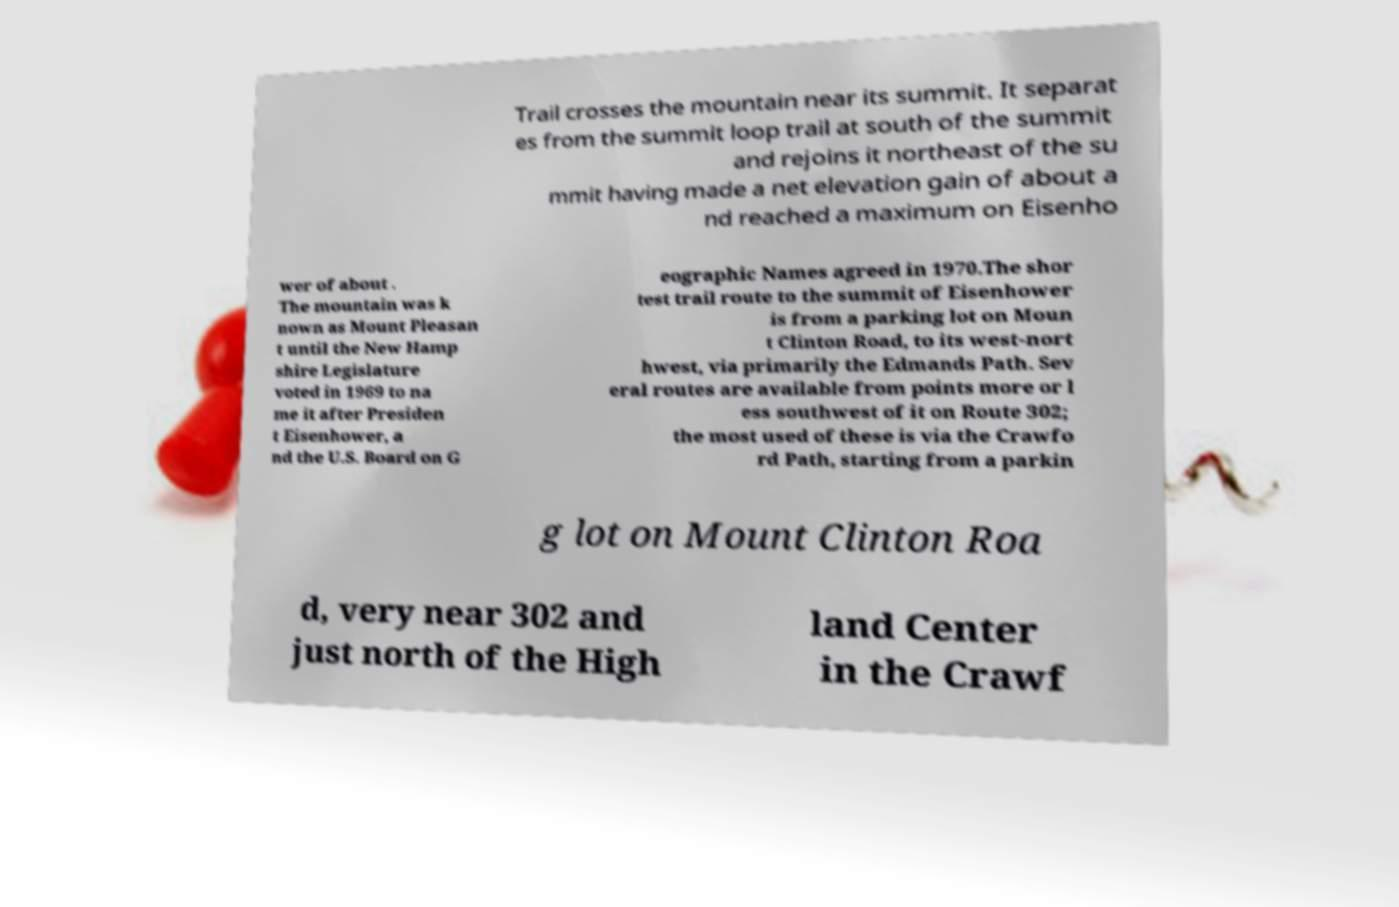Please read and relay the text visible in this image. What does it say? Trail crosses the mountain near its summit. It separat es from the summit loop trail at south of the summit and rejoins it northeast of the su mmit having made a net elevation gain of about a nd reached a maximum on Eisenho wer of about . The mountain was k nown as Mount Pleasan t until the New Hamp shire Legislature voted in 1969 to na me it after Presiden t Eisenhower, a nd the U.S. Board on G eographic Names agreed in 1970.The shor test trail route to the summit of Eisenhower is from a parking lot on Moun t Clinton Road, to its west-nort hwest, via primarily the Edmands Path. Sev eral routes are available from points more or l ess southwest of it on Route 302; the most used of these is via the Crawfo rd Path, starting from a parkin g lot on Mount Clinton Roa d, very near 302 and just north of the High land Center in the Crawf 